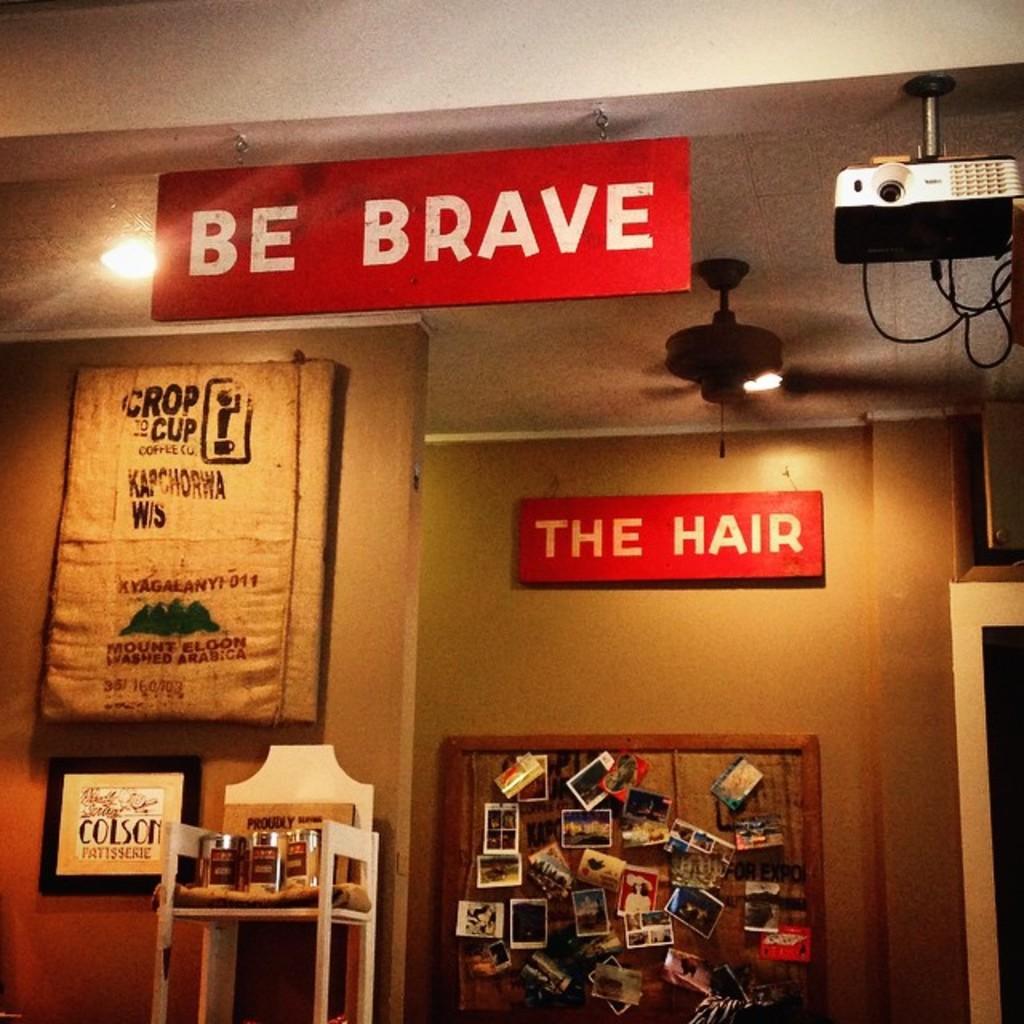What should you be?
Offer a terse response. Brave. 